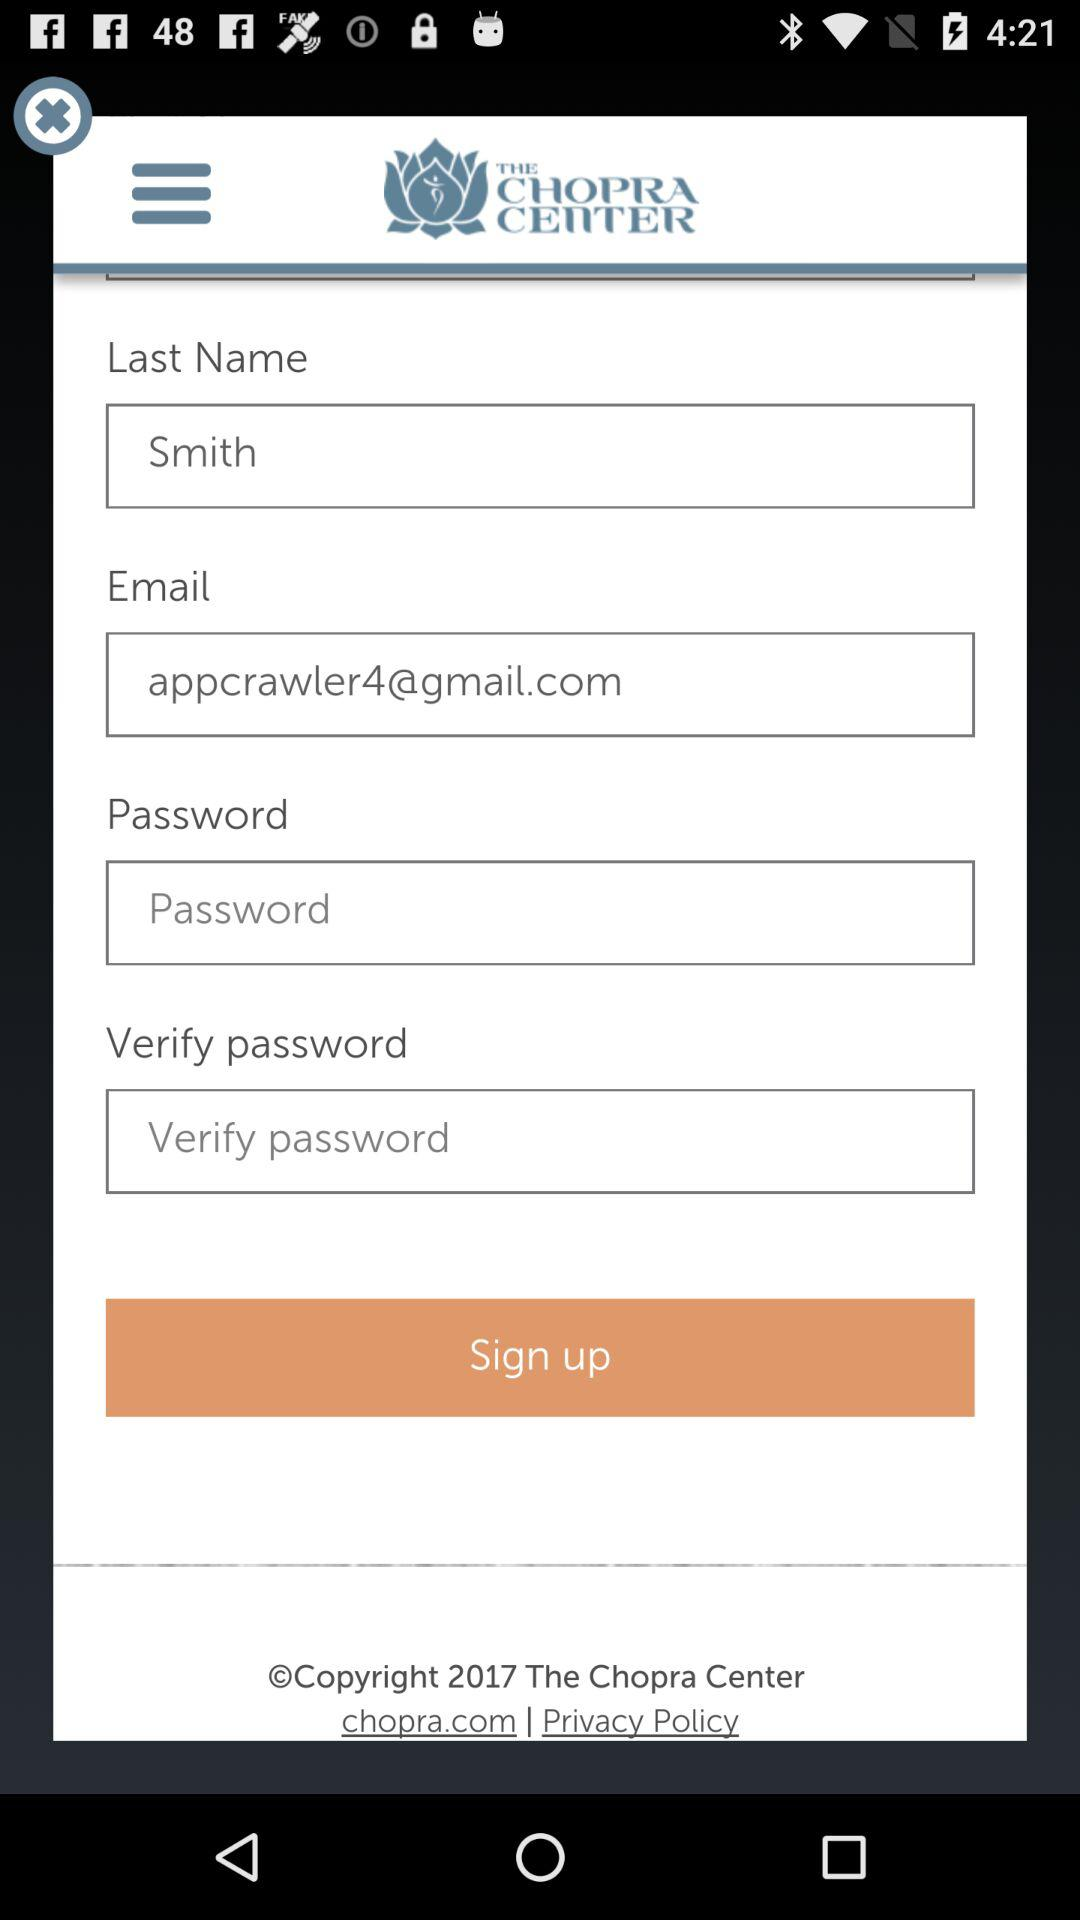What is the email address? The email address is appcrawler4@gmail.com. 